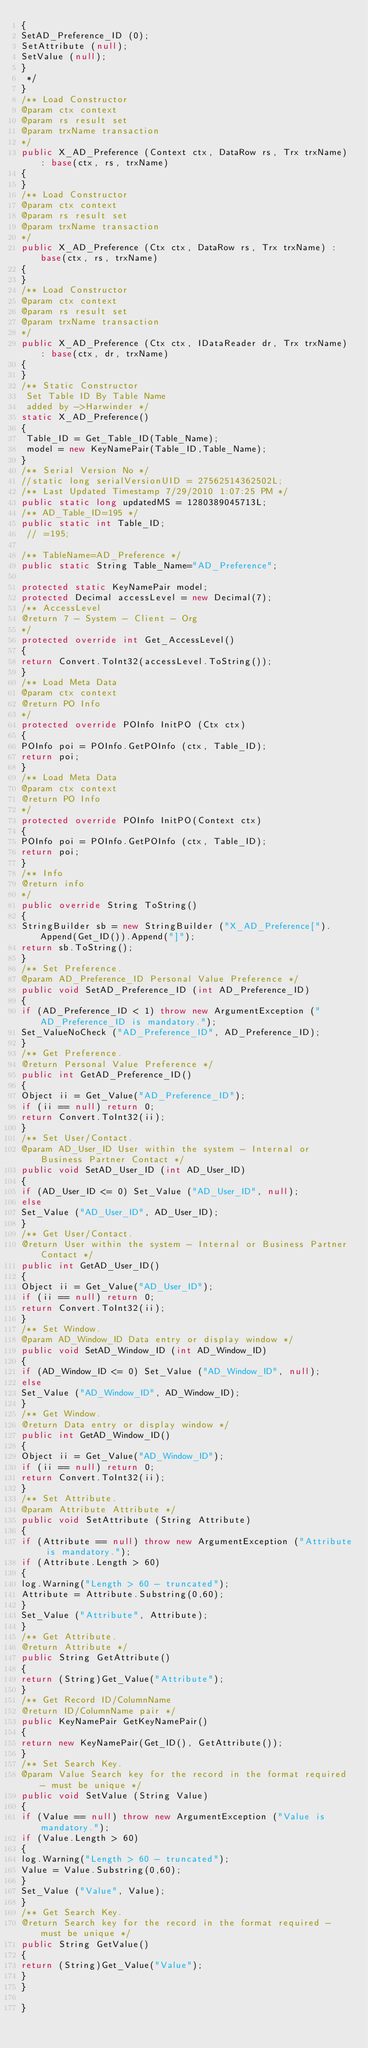<code> <loc_0><loc_0><loc_500><loc_500><_C#_>{
SetAD_Preference_ID (0);
SetAttribute (null);
SetValue (null);
}
 */
}
/** Load Constructor 
@param ctx context
@param rs result set 
@param trxName transaction
*/
public X_AD_Preference (Context ctx, DataRow rs, Trx trxName) : base(ctx, rs, trxName)
{
}
/** Load Constructor 
@param ctx context
@param rs result set 
@param trxName transaction
*/
public X_AD_Preference (Ctx ctx, DataRow rs, Trx trxName) : base(ctx, rs, trxName)
{
}
/** Load Constructor 
@param ctx context
@param rs result set 
@param trxName transaction
*/
public X_AD_Preference (Ctx ctx, IDataReader dr, Trx trxName) : base(ctx, dr, trxName)
{
}
/** Static Constructor 
 Set Table ID By Table Name
 added by ->Harwinder */
static X_AD_Preference()
{
 Table_ID = Get_Table_ID(Table_Name);
 model = new KeyNamePair(Table_ID,Table_Name);
}
/** Serial Version No */
//static long serialVersionUID = 27562514362502L;
/** Last Updated Timestamp 7/29/2010 1:07:25 PM */
public static long updatedMS = 1280389045713L;
/** AD_Table_ID=195 */
public static int Table_ID;
 // =195;

/** TableName=AD_Preference */
public static String Table_Name="AD_Preference";

protected static KeyNamePair model;
protected Decimal accessLevel = new Decimal(7);
/** AccessLevel
@return 7 - System - Client - Org 
*/
protected override int Get_AccessLevel()
{
return Convert.ToInt32(accessLevel.ToString());
}
/** Load Meta Data
@param ctx context
@return PO Info
*/
protected override POInfo InitPO (Ctx ctx)
{
POInfo poi = POInfo.GetPOInfo (ctx, Table_ID);
return poi;
}
/** Load Meta Data
@param ctx context
@return PO Info
*/
protected override POInfo InitPO(Context ctx)
{
POInfo poi = POInfo.GetPOInfo (ctx, Table_ID);
return poi;
}
/** Info
@return info
*/
public override String ToString()
{
StringBuilder sb = new StringBuilder ("X_AD_Preference[").Append(Get_ID()).Append("]");
return sb.ToString();
}
/** Set Preference.
@param AD_Preference_ID Personal Value Preference */
public void SetAD_Preference_ID (int AD_Preference_ID)
{
if (AD_Preference_ID < 1) throw new ArgumentException ("AD_Preference_ID is mandatory.");
Set_ValueNoCheck ("AD_Preference_ID", AD_Preference_ID);
}
/** Get Preference.
@return Personal Value Preference */
public int GetAD_Preference_ID() 
{
Object ii = Get_Value("AD_Preference_ID");
if (ii == null) return 0;
return Convert.ToInt32(ii);
}
/** Set User/Contact.
@param AD_User_ID User within the system - Internal or Business Partner Contact */
public void SetAD_User_ID (int AD_User_ID)
{
if (AD_User_ID <= 0) Set_Value ("AD_User_ID", null);
else
Set_Value ("AD_User_ID", AD_User_ID);
}
/** Get User/Contact.
@return User within the system - Internal or Business Partner Contact */
public int GetAD_User_ID() 
{
Object ii = Get_Value("AD_User_ID");
if (ii == null) return 0;
return Convert.ToInt32(ii);
}
/** Set Window.
@param AD_Window_ID Data entry or display window */
public void SetAD_Window_ID (int AD_Window_ID)
{
if (AD_Window_ID <= 0) Set_Value ("AD_Window_ID", null);
else
Set_Value ("AD_Window_ID", AD_Window_ID);
}
/** Get Window.
@return Data entry or display window */
public int GetAD_Window_ID() 
{
Object ii = Get_Value("AD_Window_ID");
if (ii == null) return 0;
return Convert.ToInt32(ii);
}
/** Set Attribute.
@param Attribute Attribute */
public void SetAttribute (String Attribute)
{
if (Attribute == null) throw new ArgumentException ("Attribute is mandatory.");
if (Attribute.Length > 60)
{
log.Warning("Length > 60 - truncated");
Attribute = Attribute.Substring(0,60);
}
Set_Value ("Attribute", Attribute);
}
/** Get Attribute.
@return Attribute */
public String GetAttribute() 
{
return (String)Get_Value("Attribute");
}
/** Get Record ID/ColumnName
@return ID/ColumnName pair */
public KeyNamePair GetKeyNamePair() 
{
return new KeyNamePair(Get_ID(), GetAttribute());
}
/** Set Search Key.
@param Value Search key for the record in the format required - must be unique */
public void SetValue (String Value)
{
if (Value == null) throw new ArgumentException ("Value is mandatory.");
if (Value.Length > 60)
{
log.Warning("Length > 60 - truncated");
Value = Value.Substring(0,60);
}
Set_Value ("Value", Value);
}
/** Get Search Key.
@return Search key for the record in the format required - must be unique */
public String GetValue() 
{
return (String)Get_Value("Value");
}
}

}
</code> 